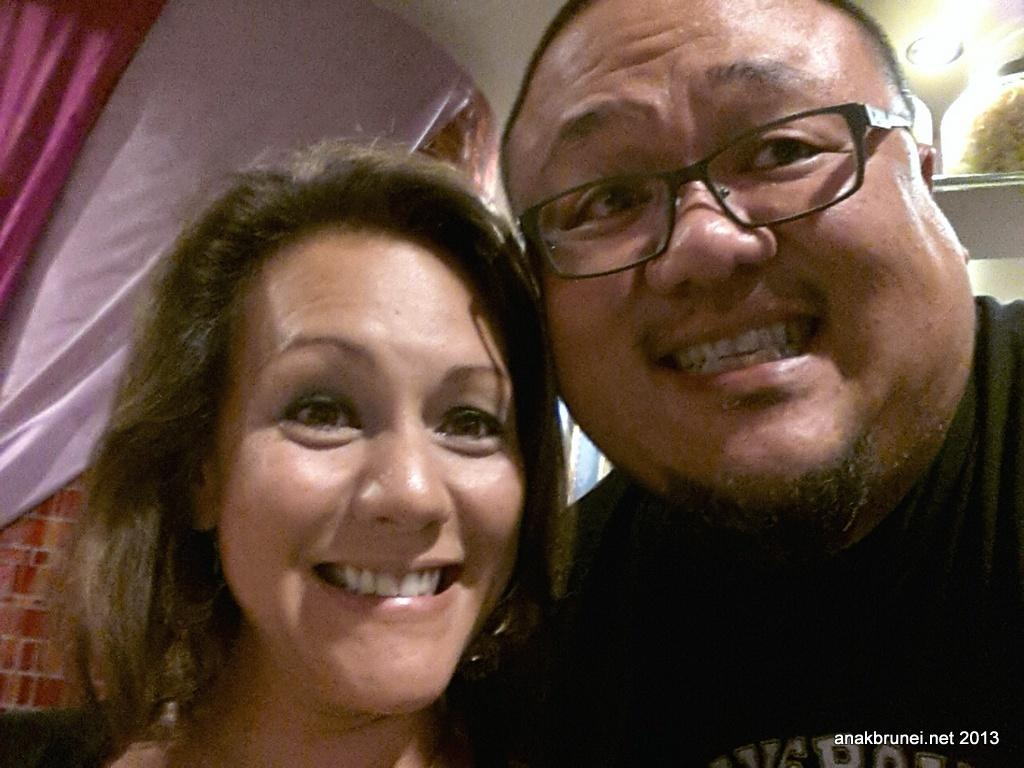Who are the people in the image? There is a girl and a boy in the image. What are the expressions on their faces? Both the girl and the boy are smiling. What type of scent can be smelled coming from the soup in the image? There is no soup present in the image, so it is not possible to determine what scent might be smelled. 